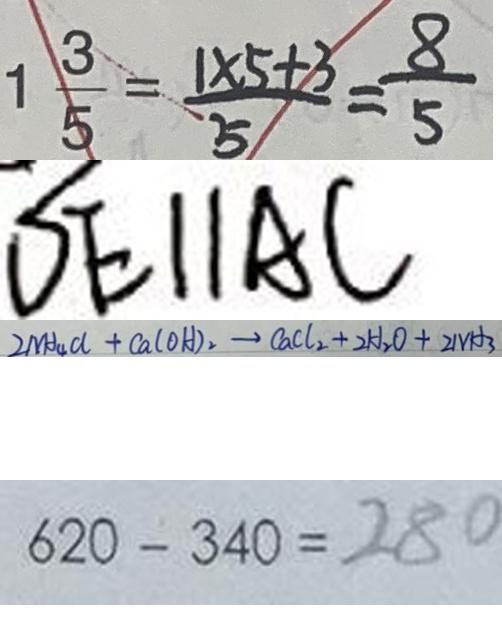<formula> <loc_0><loc_0><loc_500><loc_500>1 \frac { 3 } { 5 } = \frac { 1 \times 5 + 3 } { 5 } = \frac { 8 } { 5 } 
 D E / / A C 
 2 N H _ { 4 } C l + C a ( O H ) _ { 2 } \rightarrow C a C l _ { 2 } + 2 H _ { 2 } O + 2 N H _ { 3 } 
 6 2 0 - 3 4 0 = 2 8 0</formula> 